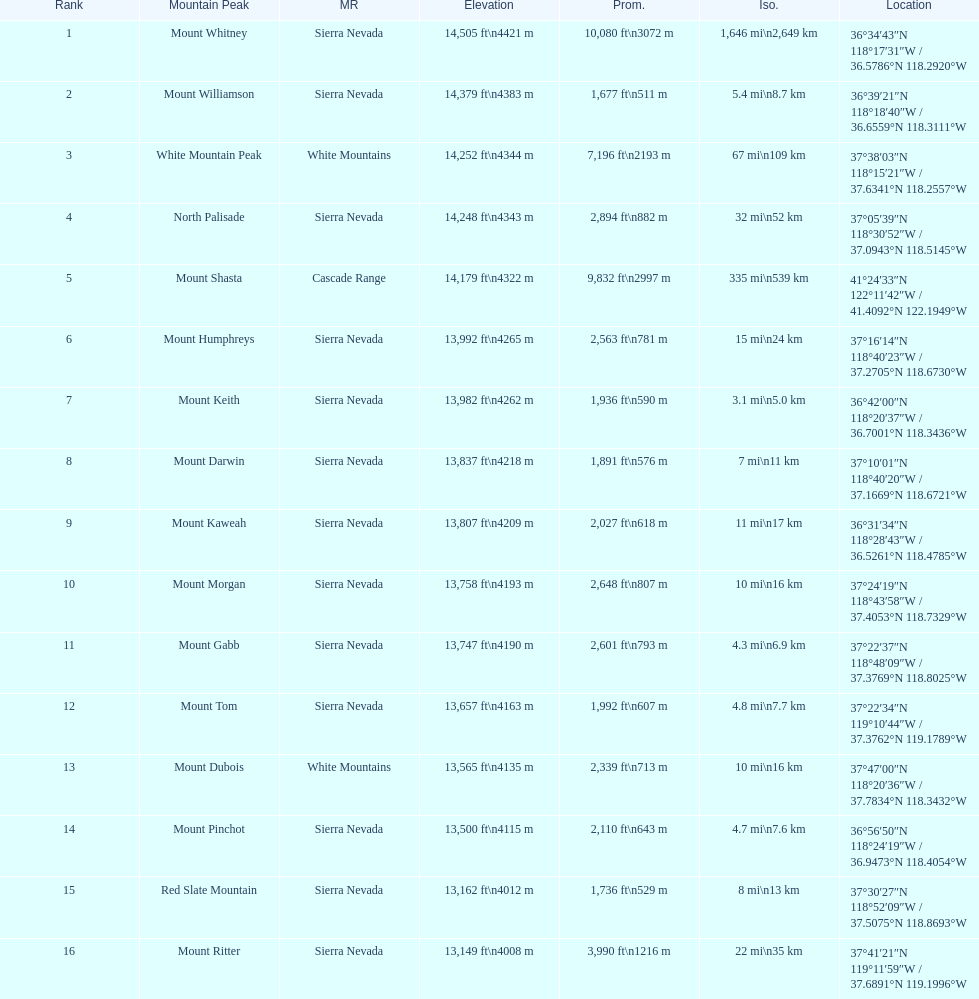In feet, what is the difference between the tallest peak and the 9th tallest peak in california? 698 ft. 